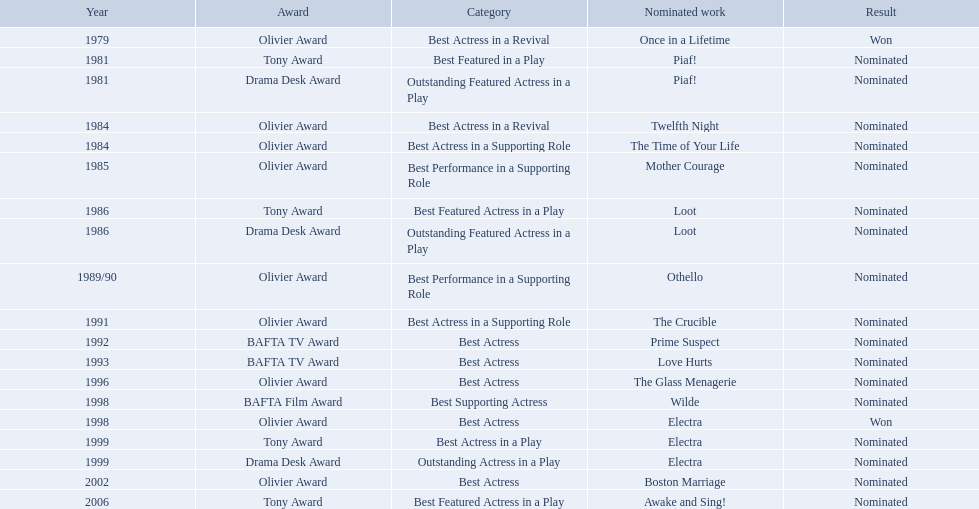Which works were nominated for the oliver award? Twelfth Night, The Time of Your Life, Mother Courage, Othello, The Crucible, The Glass Menagerie, Electra, Boston Marriage. Of these which ones did not win? Twelfth Night, The Time of Your Life, Mother Courage, Othello, The Crucible, The Glass Menagerie, Boston Marriage. Which of those were nominated for best actress of any kind in the 1080s? Twelfth Night, The Time of Your Life. Which of these was a revival? Twelfth Night. What play was wanamaker nominated outstanding featured actress in a play? Piaf!. What year was wanamaker in once in a lifetime play? 1979. What play in 1984 was wanamaker nominated best actress? Twelfth Night. For which play was wanamaker nominated as an exceptional supporting actress? Piaf!. In what year did wanamaker appear in the "once in a lifetime" play? 1979. For which 1984 play did wanamaker receive a best actress nomination? Twelfth Night. In which play did wanamaker earn a nomination for outstanding featured actress? Piaf!. During which year was wanamaker part of the "once in a lifetime" play? 1979. In 1984, for which play was wanamaker nominated as the best actress? Twelfth Night. For which play did wanamaker receive a nomination for outstanding featured actress? Piaf!. In which year did wanamaker participate in the play "once in a lifetime"? 1979. For which performance in 1984 did wanamaker earn a best actress nomination? Twelfth Night. In which play did wanamaker get nominated for outstanding featured actress? Piaf!. When did wanamaker appear in the play "once in a lifetime"? 1979. What was the play in 1984 where wanamaker was nominated for best actress? Twelfth Night. Which play resulted in wanamaker's nomination for outstanding featured actress? Piaf!. In what year did wanamaker perform in "once in a lifetime"? 1979. For which 1984 play did wanamaker receive a best actress nomination? Twelfth Night. 